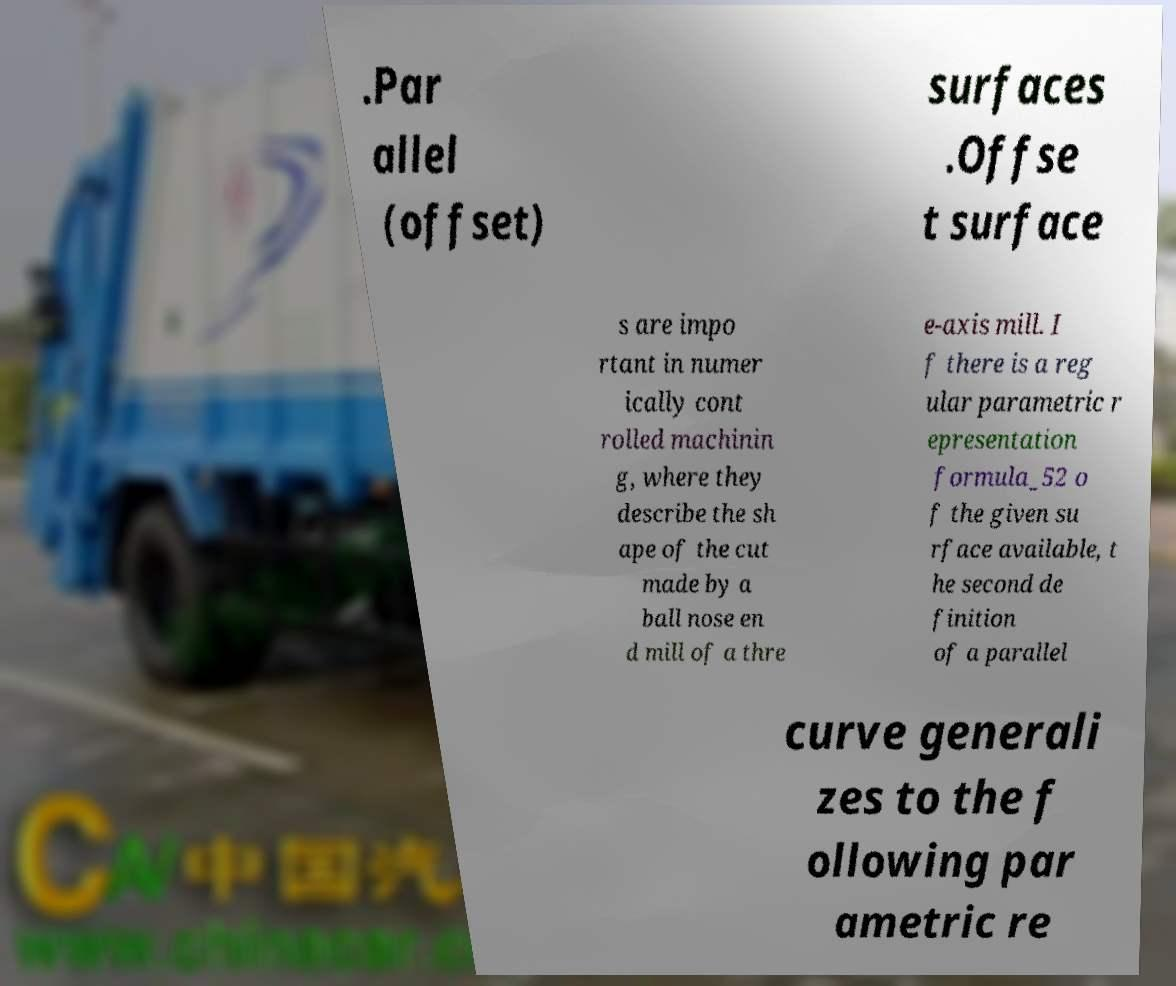Can you accurately transcribe the text from the provided image for me? .Par allel (offset) surfaces .Offse t surface s are impo rtant in numer ically cont rolled machinin g, where they describe the sh ape of the cut made by a ball nose en d mill of a thre e-axis mill. I f there is a reg ular parametric r epresentation formula_52 o f the given su rface available, t he second de finition of a parallel curve generali zes to the f ollowing par ametric re 